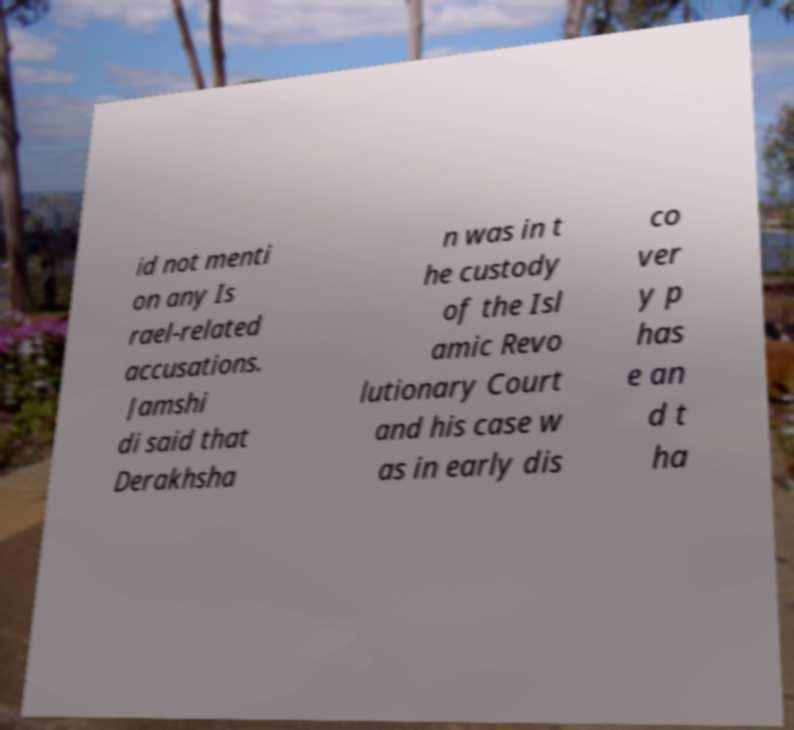Could you extract and type out the text from this image? id not menti on any Is rael-related accusations. Jamshi di said that Derakhsha n was in t he custody of the Isl amic Revo lutionary Court and his case w as in early dis co ver y p has e an d t ha 